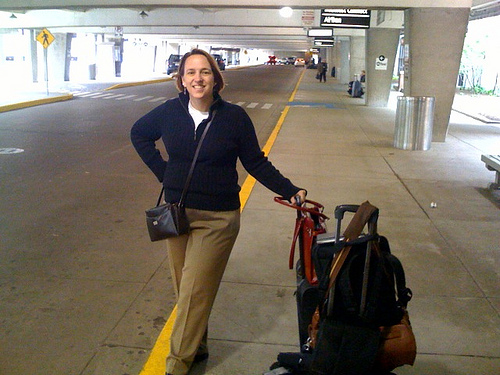How does the setting contribute to the overall mood of the image? The setting appears to be an airport or bus terminal, which contributes significantly to the mood of anticipation and transition. The wide, open space ahead and the signs of other travelers moving in the background give a sense of journey and forward momentum. The environment is both transient and bustling, amplifying the themes of travel and future possibilities. What emotion does the woman portray in the image? The woman portrays a sense of confidence and readiness. Her smile indicates happiness or contentment, possibly reflecting excitement about her travel plans. She stands poised, with a hand on her hip, suggesting a relaxed and assured attitude. 